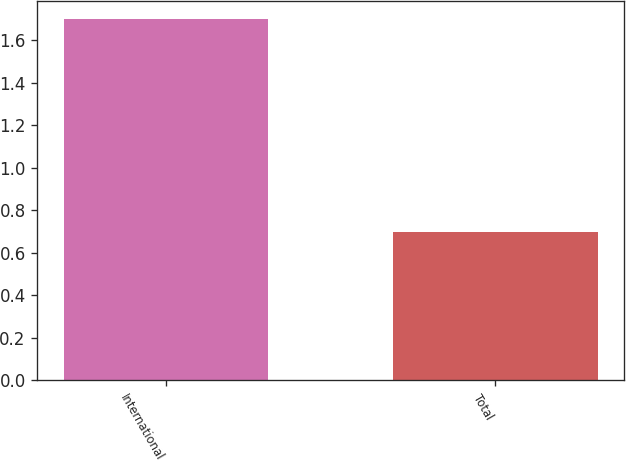Convert chart to OTSL. <chart><loc_0><loc_0><loc_500><loc_500><bar_chart><fcel>International<fcel>Total<nl><fcel>1.7<fcel>0.7<nl></chart> 